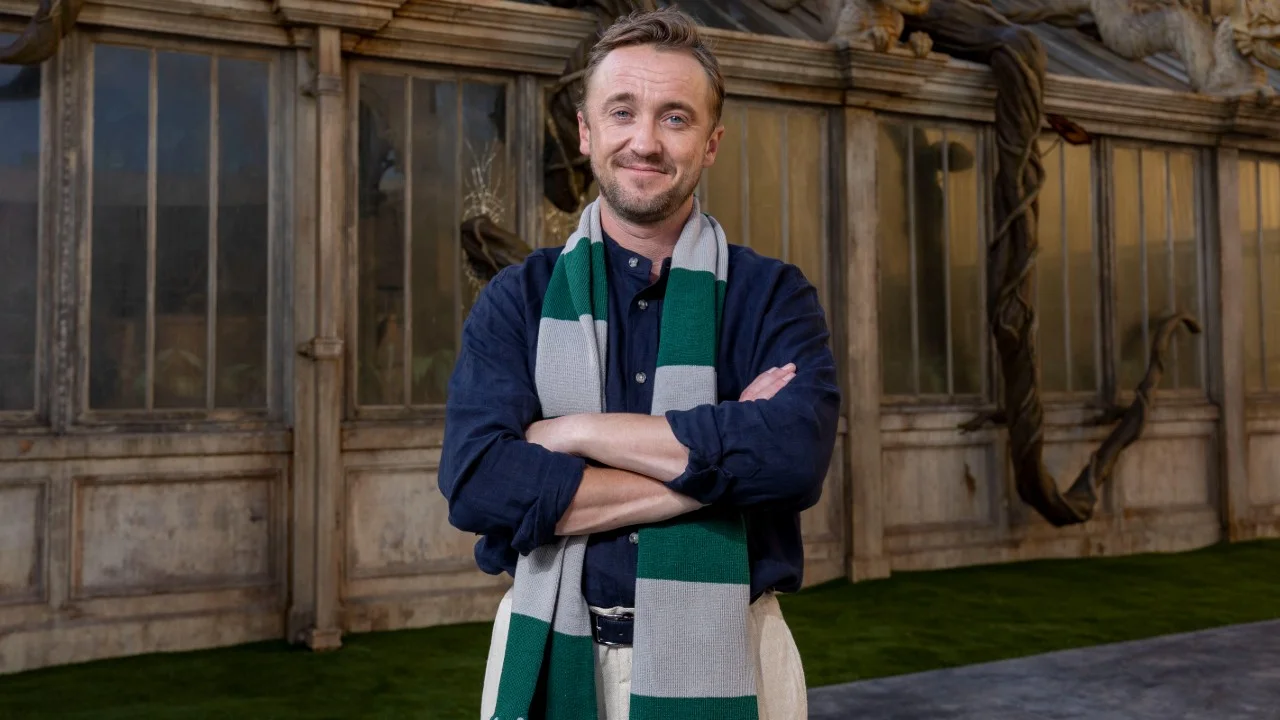If this scene were part of a larger narrative, what themes might be explored? In a larger narrative, this scene could explore themes of reflection, growth, and the interplay between humanity and nature. The character's serene demeanor amidst the aged architecture and encroaching plant life may symbolize the harmony that can be achieved between human constructs and the natural world. Themes of legacy and stewardship might also be prominent, with the character acting as a bridge between past traditions and future innovations. Additionally, this setting could delve into concepts of inner peace and the journey towards self-discovery, illustrating how external environments can reflect and influence an individual's internal state. What adventures might the character embark on next? The character might embark on a series of riveting adventures that involve uncovering ancient secrets, safeguarding mystical relics, and mediating between warring realms. With his command over elemental magic and ability to weave the veil between worlds, he could be drawn into quests that require his unique abilities to prevent catastrophes, heal rifts between different magical entities, and guide lost souls back to their rightful paths. Perhaps there are dark forces rising, threatening to disrupt the balance he maintains, and he must ally with both old friends and new companions to thwart their nefarious plans. Each adventure would not only test his skills but also teach him more about his own lineage, the limits and possibilities of his powers, and the true meaning of being a guardian. 